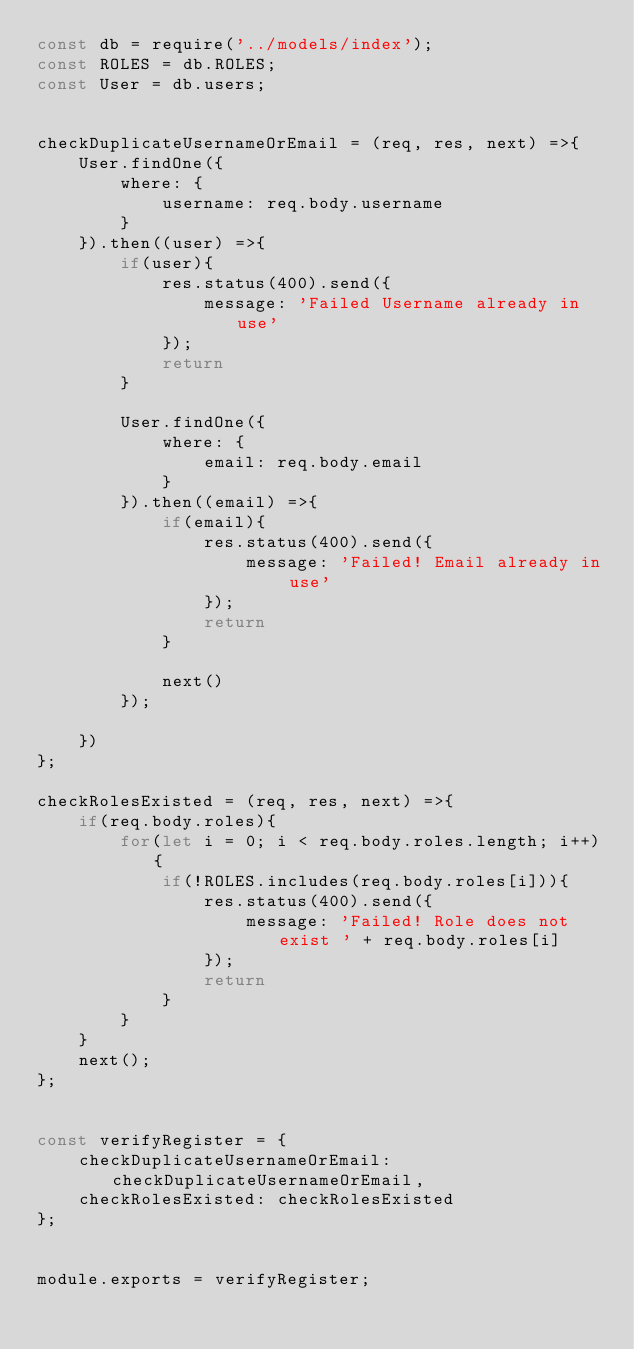<code> <loc_0><loc_0><loc_500><loc_500><_JavaScript_>const db = require('../models/index');
const ROLES = db.ROLES;
const User = db.users;


checkDuplicateUsernameOrEmail = (req, res, next) =>{
    User.findOne({
        where: {
            username: req.body.username
        }
    }).then((user) =>{
        if(user){
            res.status(400).send({
                message: 'Failed Username already in use'
            });
            return
        }

        User.findOne({
            where: {
                email: req.body.email
            }
        }).then((email) =>{
            if(email){
                res.status(400).send({
                    message: 'Failed! Email already in use'
                });
                return
            }

            next()
        });

    })
};

checkRolesExisted = (req, res, next) =>{
    if(req.body.roles){
        for(let i = 0; i < req.body.roles.length; i++){
            if(!ROLES.includes(req.body.roles[i])){
                res.status(400).send({
                    message: 'Failed! Role does not exist ' + req.body.roles[i]
                });
                return
            }
        }
    }
    next();
};


const verifyRegister = {
    checkDuplicateUsernameOrEmail: checkDuplicateUsernameOrEmail,
    checkRolesExisted: checkRolesExisted
};


module.exports = verifyRegister;</code> 